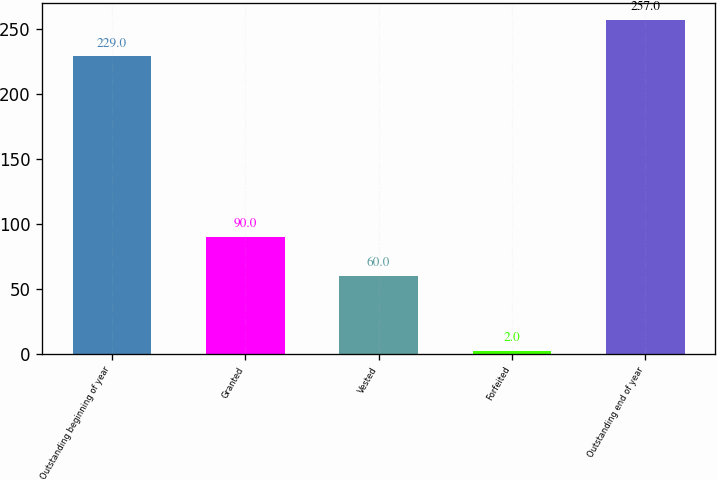Convert chart. <chart><loc_0><loc_0><loc_500><loc_500><bar_chart><fcel>Outstanding beginning of year<fcel>Granted<fcel>Vested<fcel>Forfeited<fcel>Outstanding end of year<nl><fcel>229<fcel>90<fcel>60<fcel>2<fcel>257<nl></chart> 